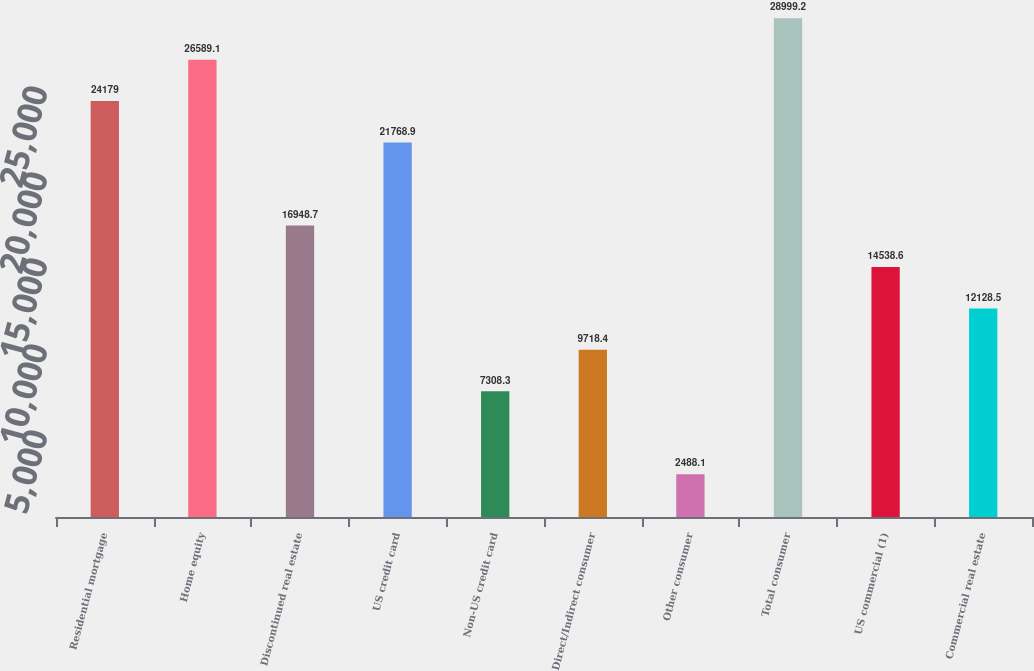Convert chart to OTSL. <chart><loc_0><loc_0><loc_500><loc_500><bar_chart><fcel>Residential mortgage<fcel>Home equity<fcel>Discontinued real estate<fcel>US credit card<fcel>Non-US credit card<fcel>Direct/Indirect consumer<fcel>Other consumer<fcel>Total consumer<fcel>US commercial (1)<fcel>Commercial real estate<nl><fcel>24179<fcel>26589.1<fcel>16948.7<fcel>21768.9<fcel>7308.3<fcel>9718.4<fcel>2488.1<fcel>28999.2<fcel>14538.6<fcel>12128.5<nl></chart> 